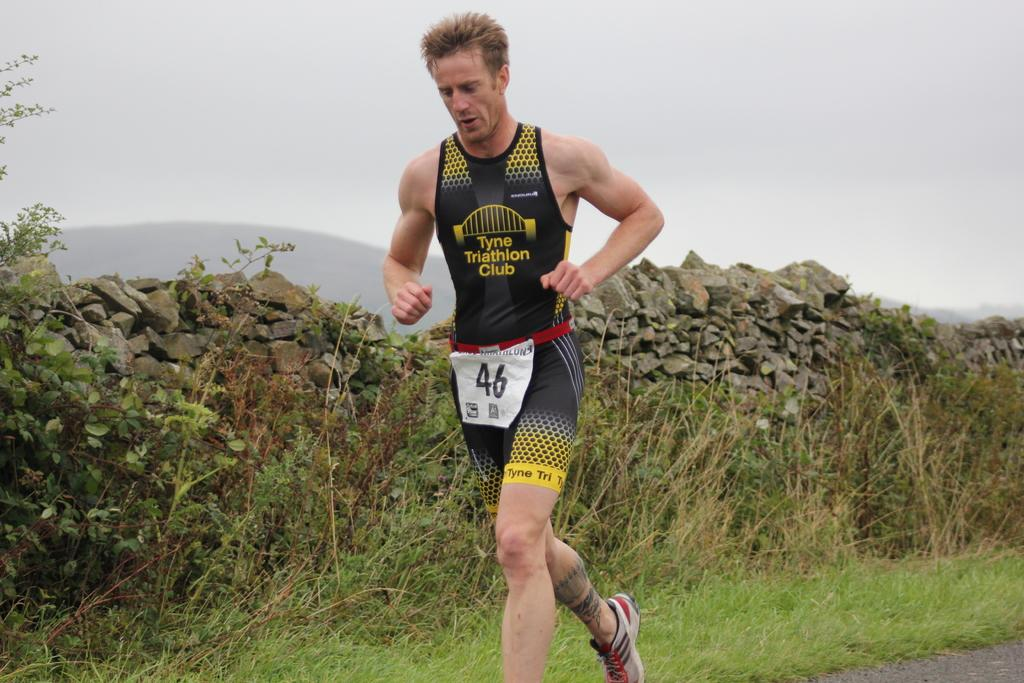<image>
Relay a brief, clear account of the picture shown. A runner from the Tyne Triathlon Club is identified as number 46. 46. 